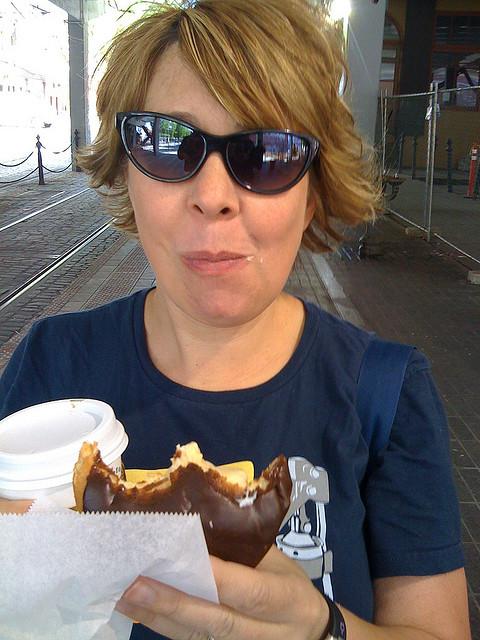What does the woman have next to the corner of her mouth?
Quick response, please. Crumb. Does this woman drink coffee?
Give a very brief answer. Yes. Is the woman wearing sunglasses?
Be succinct. Yes. 